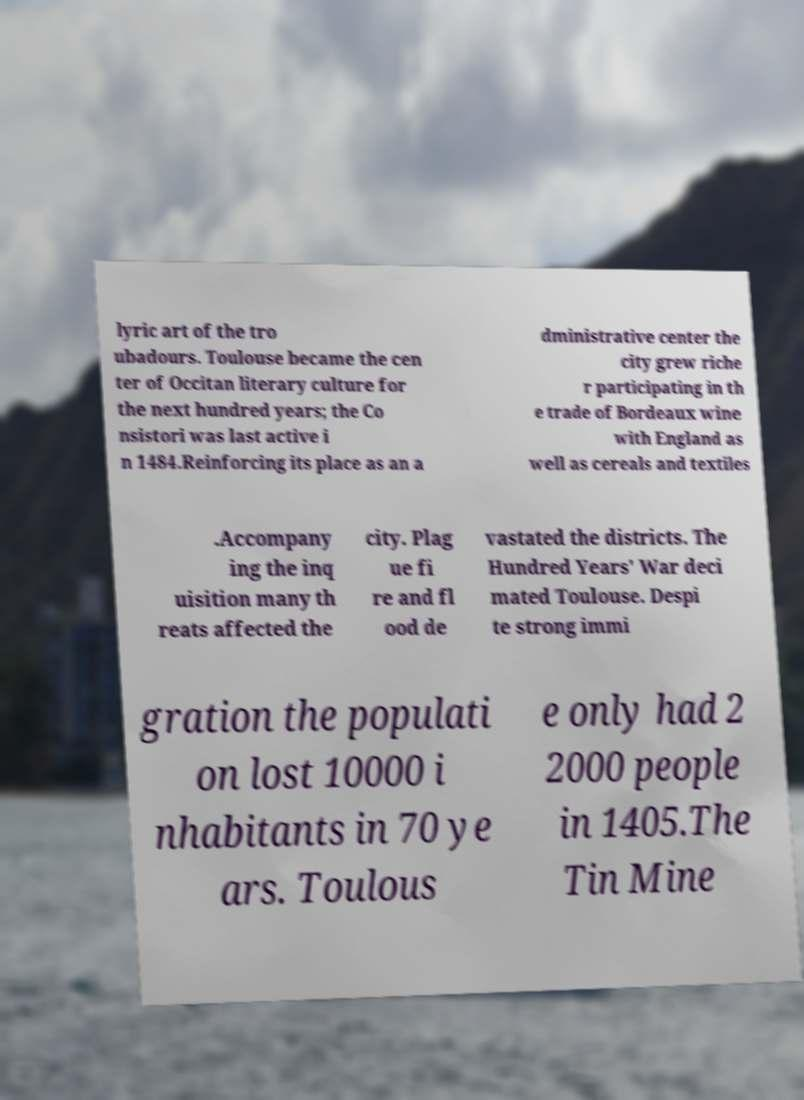Could you extract and type out the text from this image? lyric art of the tro ubadours. Toulouse became the cen ter of Occitan literary culture for the next hundred years; the Co nsistori was last active i n 1484.Reinforcing its place as an a dministrative center the city grew riche r participating in th e trade of Bordeaux wine with England as well as cereals and textiles .Accompany ing the inq uisition many th reats affected the city. Plag ue fi re and fl ood de vastated the districts. The Hundred Years' War deci mated Toulouse. Despi te strong immi gration the populati on lost 10000 i nhabitants in 70 ye ars. Toulous e only had 2 2000 people in 1405.The Tin Mine 